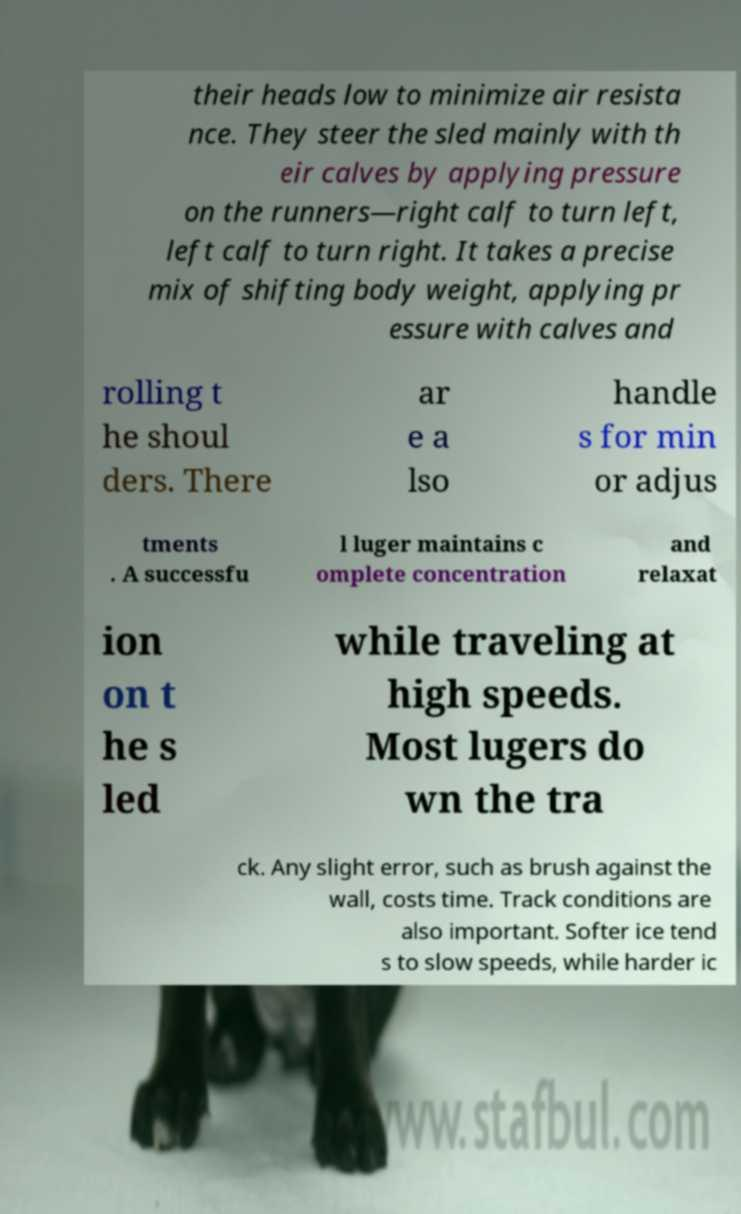There's text embedded in this image that I need extracted. Can you transcribe it verbatim? their heads low to minimize air resista nce. They steer the sled mainly with th eir calves by applying pressure on the runners—right calf to turn left, left calf to turn right. It takes a precise mix of shifting body weight, applying pr essure with calves and rolling t he shoul ders. There ar e a lso handle s for min or adjus tments . A successfu l luger maintains c omplete concentration and relaxat ion on t he s led while traveling at high speeds. Most lugers do wn the tra ck. Any slight error, such as brush against the wall, costs time. Track conditions are also important. Softer ice tend s to slow speeds, while harder ic 